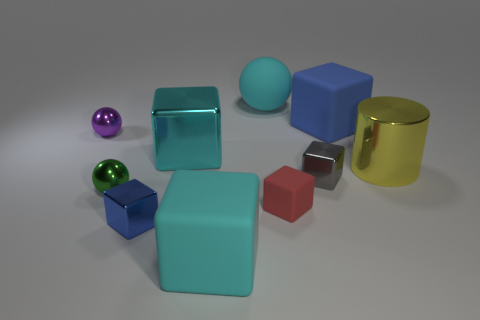Subtract all blue cubes. How many cubes are left? 4 Subtract all purple balls. How many balls are left? 2 Subtract all cubes. How many objects are left? 4 Subtract all green cylinders. Subtract all red balls. How many cylinders are left? 1 Subtract all brown cubes. How many cyan cylinders are left? 0 Subtract all big metallic cubes. Subtract all tiny purple matte cylinders. How many objects are left? 9 Add 3 large yellow cylinders. How many large yellow cylinders are left? 4 Add 3 gray metallic objects. How many gray metallic objects exist? 4 Subtract 1 gray cubes. How many objects are left? 9 Subtract 2 spheres. How many spheres are left? 1 